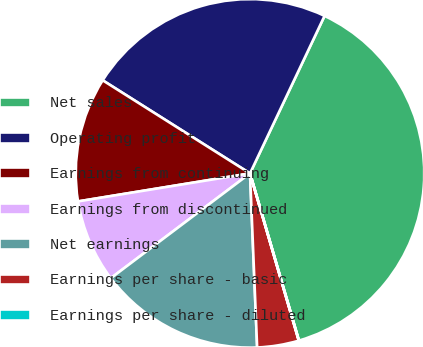Convert chart to OTSL. <chart><loc_0><loc_0><loc_500><loc_500><pie_chart><fcel>Net sales<fcel>Operating profit<fcel>Earnings from continuing<fcel>Earnings from discontinued<fcel>Net earnings<fcel>Earnings per share - basic<fcel>Earnings per share - diluted<nl><fcel>38.43%<fcel>23.07%<fcel>11.54%<fcel>7.7%<fcel>15.38%<fcel>3.86%<fcel>0.02%<nl></chart> 